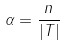Convert formula to latex. <formula><loc_0><loc_0><loc_500><loc_500>\alpha = \frac { n } { | T | }</formula> 